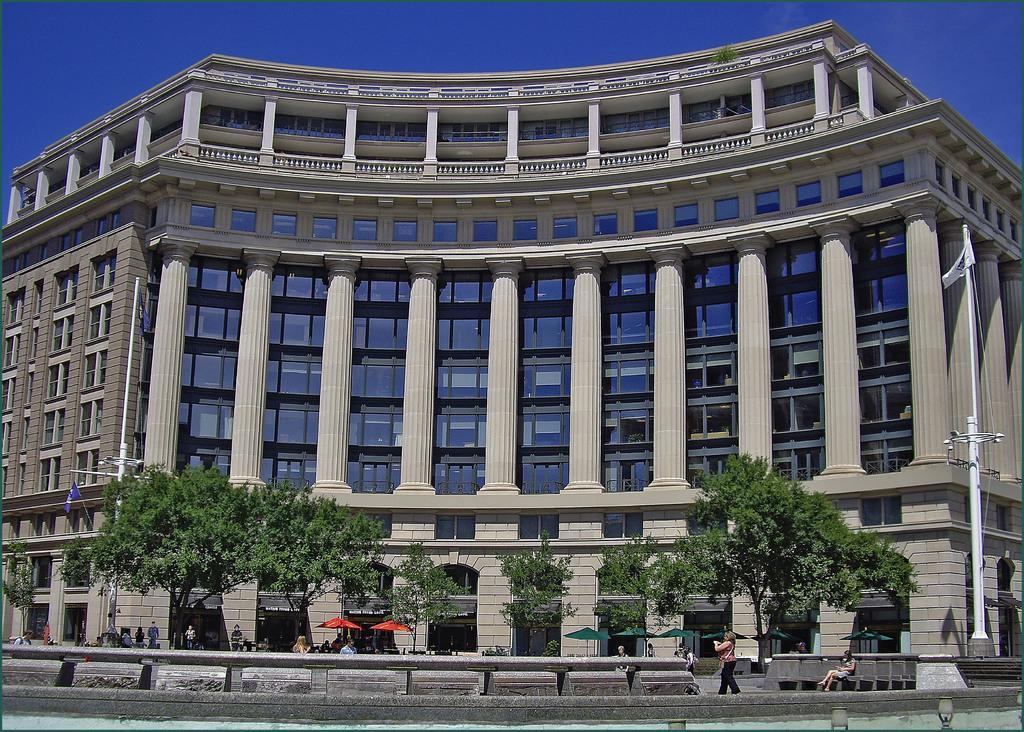Can you describe this image briefly? In this image there is a building, poles, flags, trees, umbrellas, people, pillars, blue sky and objects. 